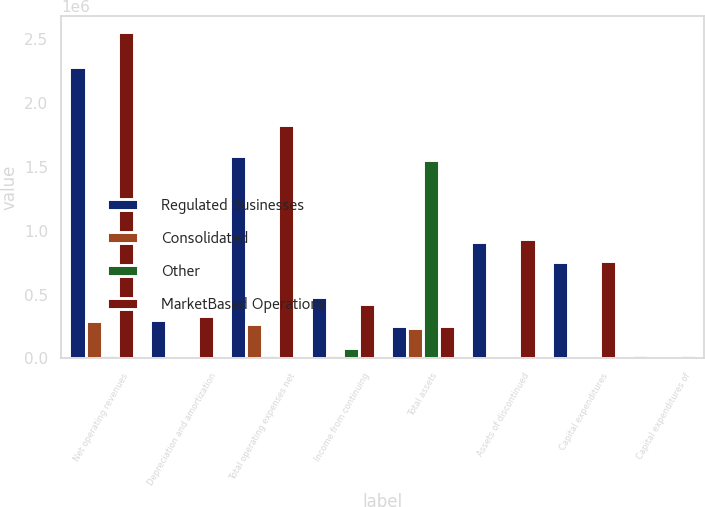Convert chart. <chart><loc_0><loc_0><loc_500><loc_500><stacked_bar_chart><ecel><fcel>Net operating revenues<fcel>Depreciation and amortization<fcel>Total operating expenses net<fcel>Income from continuing<fcel>Total assets<fcel>Assets of discontinued<fcel>Capital expenditures<fcel>Capital expenditures of<nl><fcel>Regulated Businesses<fcel>2.28566e+06<fcel>301087<fcel>1.58796e+06<fcel>478629<fcel>254888<fcel>911905<fcel>758150<fcel>26725<nl><fcel>Consolidated<fcel>294723<fcel>7014<fcel>269059<fcel>30416<fcel>240718<fcel>6590<fcel>7486<fcel>143<nl><fcel>Other<fcel>25344<fcel>22163<fcel>30109<fcel>79621<fcel>1.55473e+06<fcel>19210<fcel>0<fcel>0<nl><fcel>MarketBased Operations<fcel>2.55504e+06<fcel>330264<fcel>1.82691e+06<fcel>429424<fcel>254888<fcel>937705<fcel>765636<fcel>26868<nl></chart> 